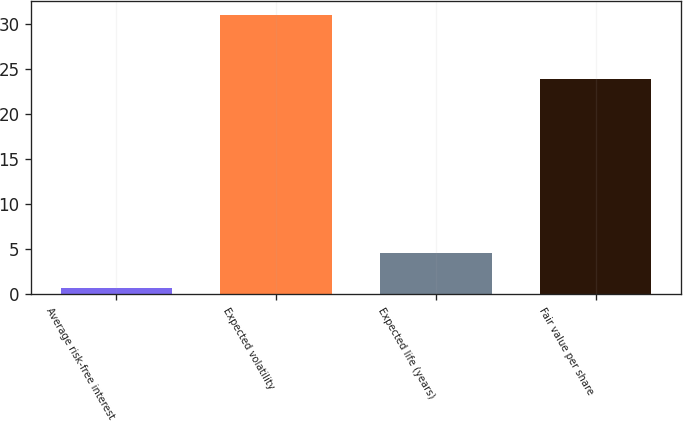Convert chart to OTSL. <chart><loc_0><loc_0><loc_500><loc_500><bar_chart><fcel>Average risk-free interest<fcel>Expected volatility<fcel>Expected life (years)<fcel>Fair value per share<nl><fcel>0.7<fcel>31<fcel>4.6<fcel>23.93<nl></chart> 